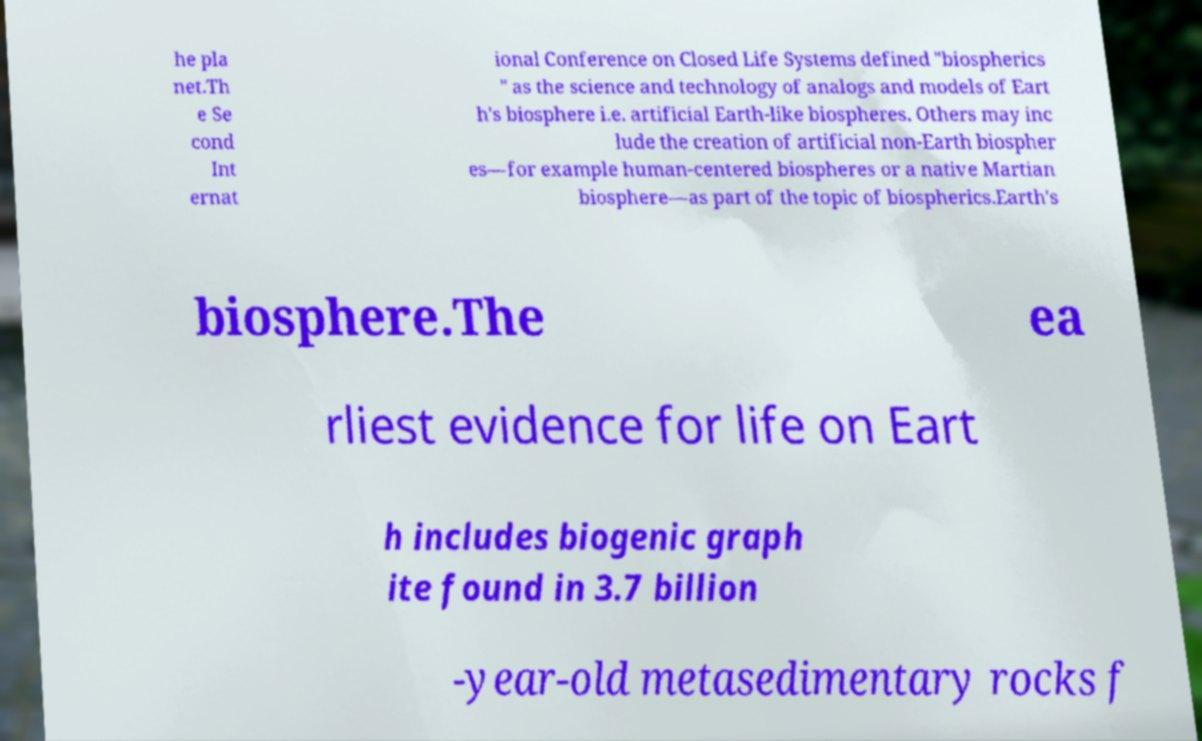Can you accurately transcribe the text from the provided image for me? he pla net.Th e Se cond Int ernat ional Conference on Closed Life Systems defined "biospherics " as the science and technology of analogs and models of Eart h's biosphere i.e. artificial Earth-like biospheres. Others may inc lude the creation of artificial non-Earth biospher es—for example human-centered biospheres or a native Martian biosphere—as part of the topic of biospherics.Earth's biosphere.The ea rliest evidence for life on Eart h includes biogenic graph ite found in 3.7 billion -year-old metasedimentary rocks f 